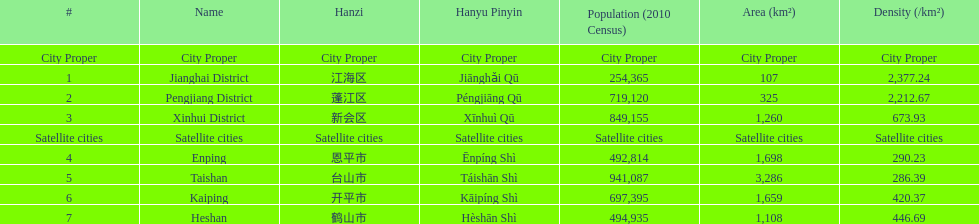Help me parse the entirety of this table. {'header': ['#', 'Name', 'Hanzi', 'Hanyu Pinyin', 'Population (2010 Census)', 'Area (km²)', 'Density (/km²)'], 'rows': [['City Proper', 'City Proper', 'City Proper', 'City Proper', 'City Proper', 'City Proper', 'City Proper'], ['1', 'Jianghai District', '江海区', 'Jiānghǎi Qū', '254,365', '107', '2,377.24'], ['2', 'Pengjiang District', '蓬江区', 'Péngjiāng Qū', '719,120', '325', '2,212.67'], ['3', 'Xinhui District', '新会区', 'Xīnhuì Qū', '849,155', '1,260', '673.93'], ['Satellite cities', 'Satellite cities', 'Satellite cities', 'Satellite cities', 'Satellite cities', 'Satellite cities', 'Satellite cities'], ['4', 'Enping', '恩平市', 'Ēnpíng Shì', '492,814', '1,698', '290.23'], ['5', 'Taishan', '台山市', 'Táishān Shì', '941,087', '3,286', '286.39'], ['6', 'Kaiping', '开平市', 'Kāipíng Shì', '697,395', '1,659', '420.37'], ['7', 'Heshan', '鹤山市', 'Hèshān Shì', '494,935', '1,108', '446.69']]} Which area under the satellite cities has the most in population? Taishan. 